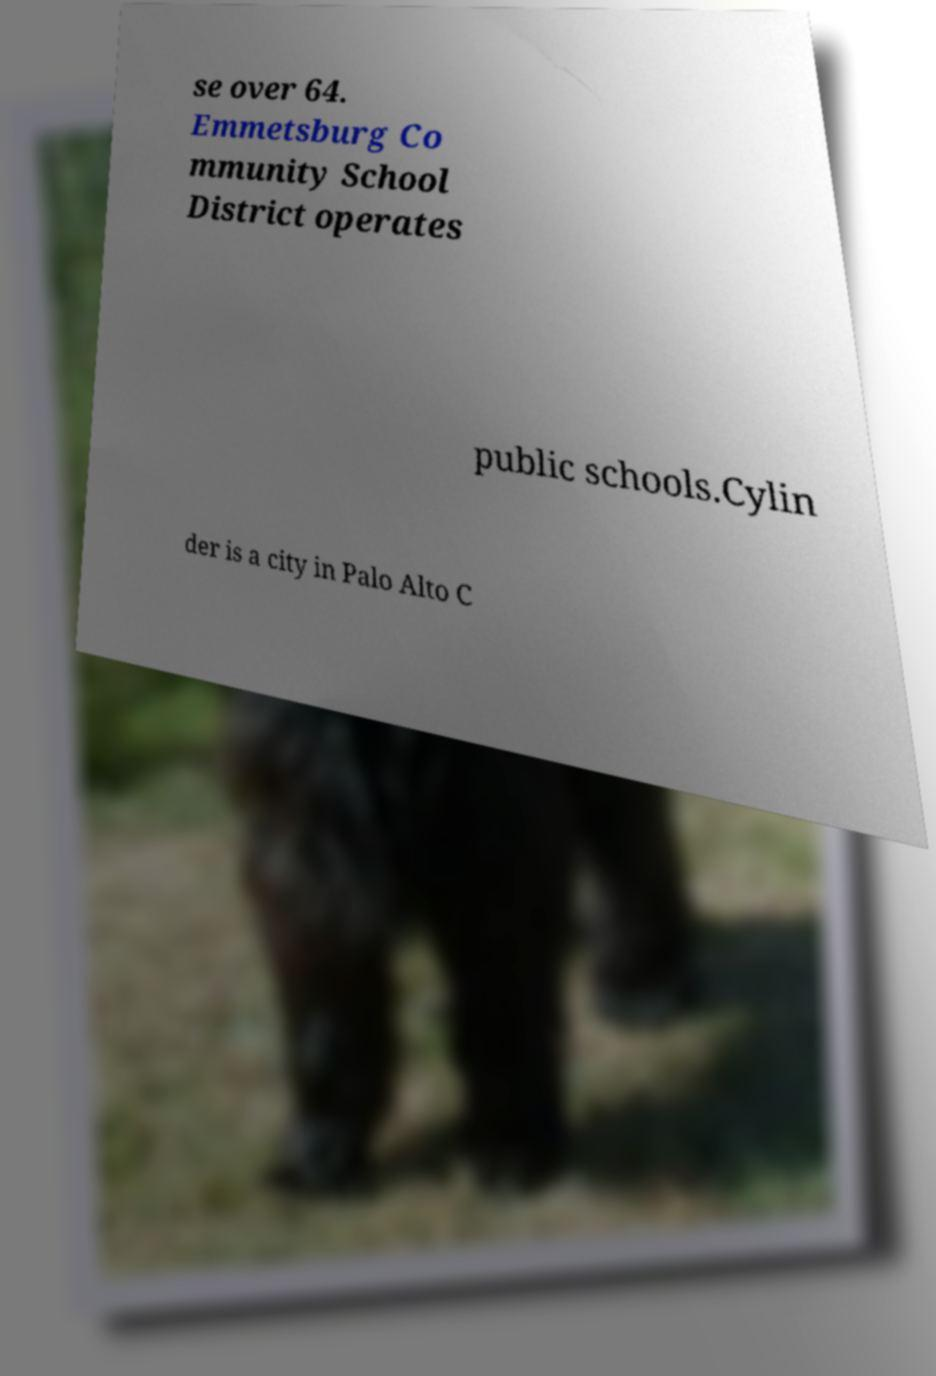Please identify and transcribe the text found in this image. se over 64. Emmetsburg Co mmunity School District operates public schools.Cylin der is a city in Palo Alto C 